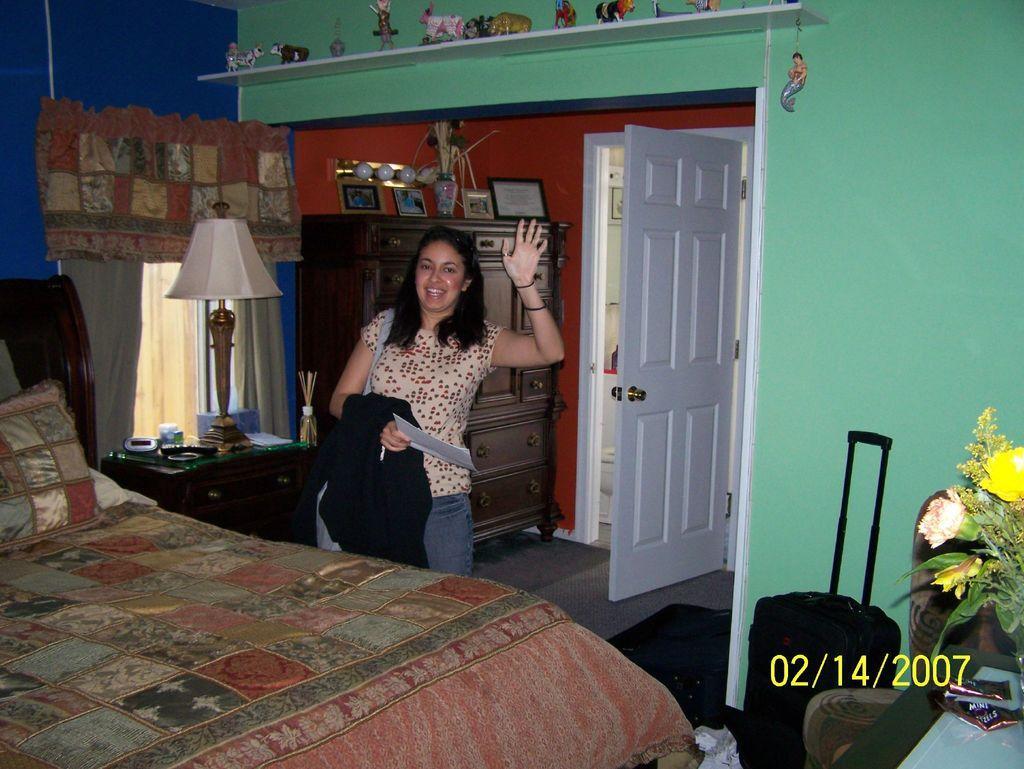Can you describe this image briefly? In this picture we can see woman standing on floor holding paper and pen in her hand and smiling and in front of her we can see bed on bed pillow and aside to that table and on table remote, lamp and in background we can see curtain, cupboards, vase, frames, bulbs, toys, door, wall, suitcase, flowers. 